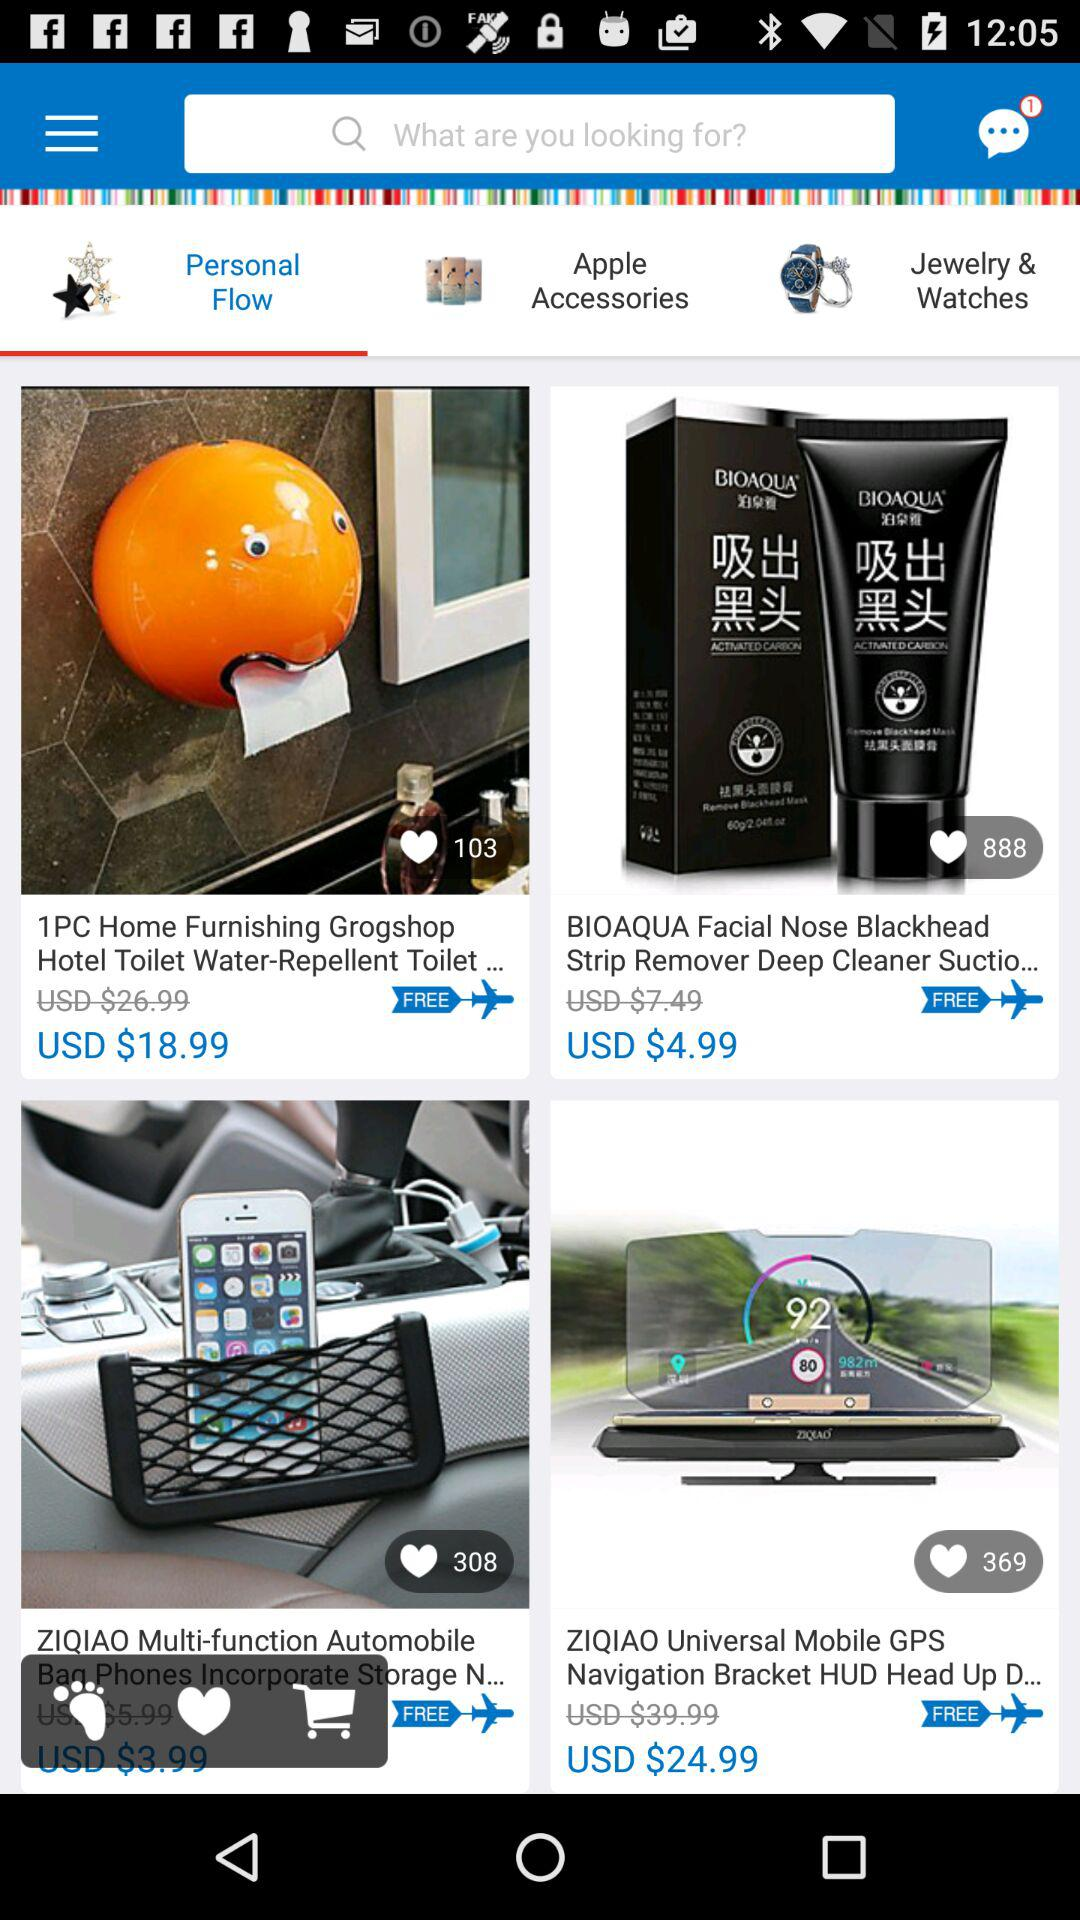What is the original price of the "1PC Home Furnishing Grogshop Hotel Toilet Water-Repellent Toilet..."? The original price of the "1PC Home Furnishing Grogshop Hotel Toilet Water-Repellent Toilet..." is USD $26.99. 